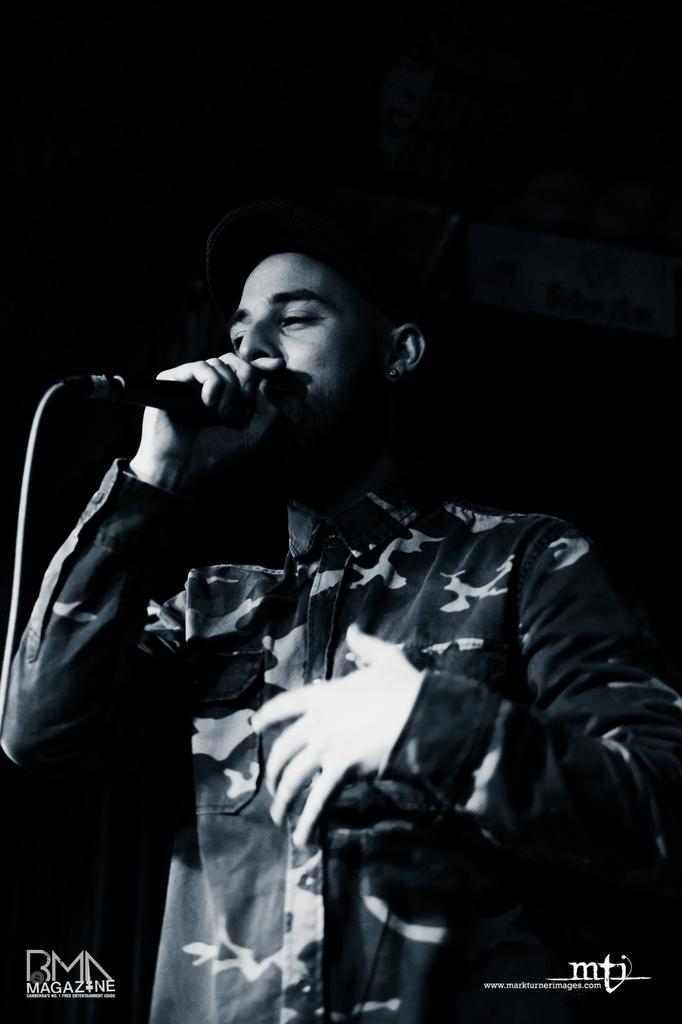What is the main subject of the image? There is a person in the image. What is the person doing in the image? The person is standing and singing. What object is the person using while singing? The person is using a microphone while singing. Can you tell me how many chickens are on the person's head in the image? There are no chickens present on the person's head in the image. What type of haircut does the person have in the image? The provided facts do not mention the person's haircut, so it cannot be determined from the image. 